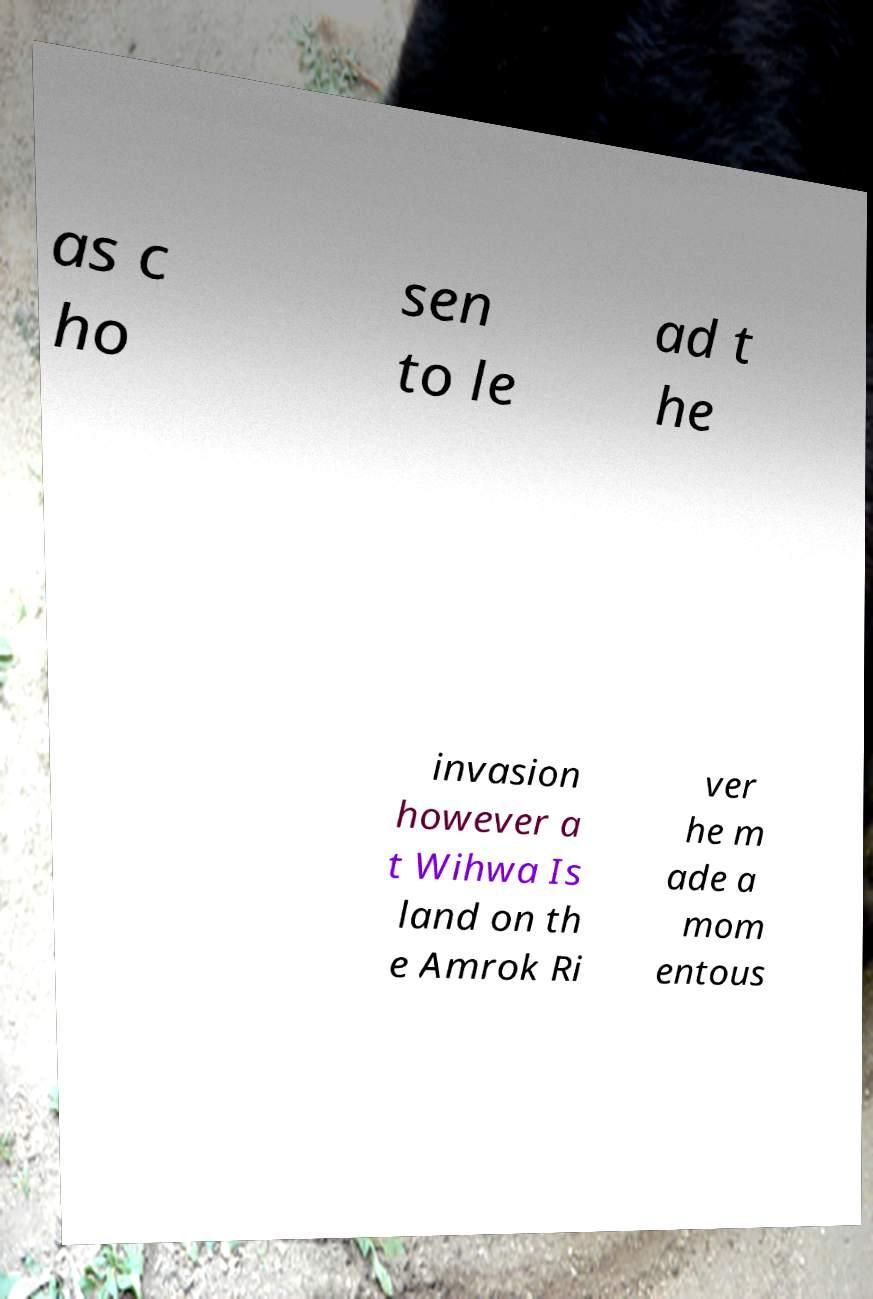Please read and relay the text visible in this image. What does it say? as c ho sen to le ad t he invasion however a t Wihwa Is land on th e Amrok Ri ver he m ade a mom entous 